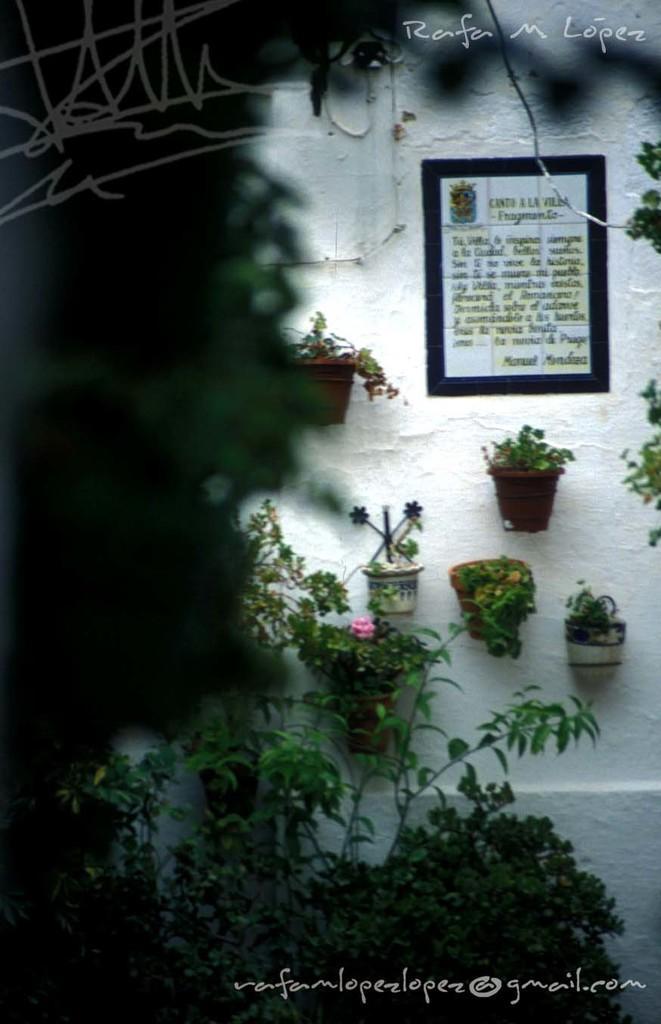In one or two sentences, can you explain what this image depicts? In this image, I can see the plants in flower pots and a frame are attached to the wall. At the top and bottom of the image, there are watermarks. 